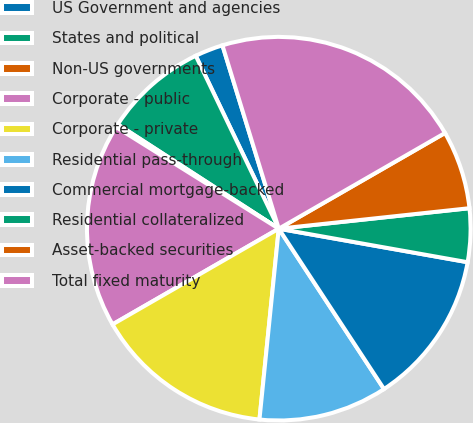<chart> <loc_0><loc_0><loc_500><loc_500><pie_chart><fcel>US Government and agencies<fcel>States and political<fcel>Non-US governments<fcel>Corporate - public<fcel>Corporate - private<fcel>Residential pass-through<fcel>Commercial mortgage-backed<fcel>Residential collateralized<fcel>Asset-backed securities<fcel>Total fixed maturity<nl><fcel>2.38%<fcel>8.73%<fcel>0.26%<fcel>17.2%<fcel>15.08%<fcel>10.85%<fcel>12.96%<fcel>4.5%<fcel>6.61%<fcel>21.43%<nl></chart> 